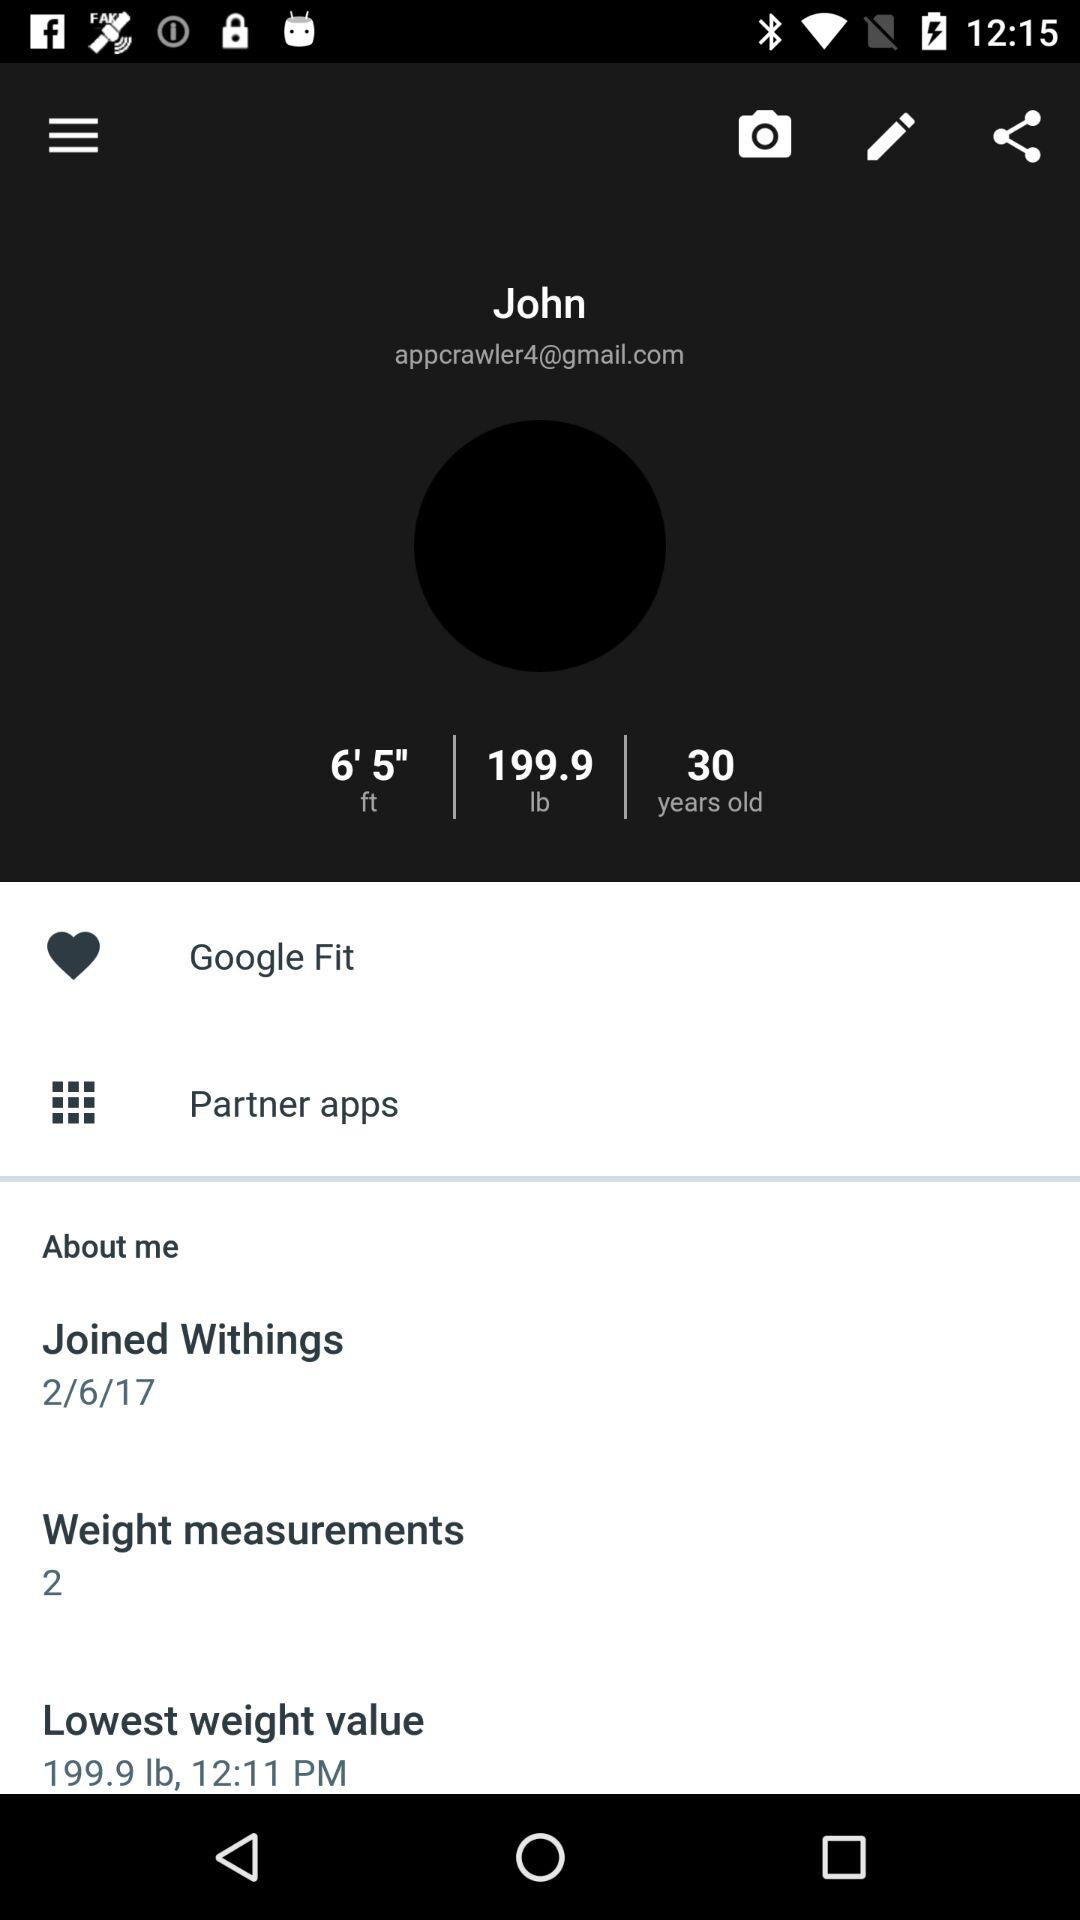What is the user name? The user name is John. 